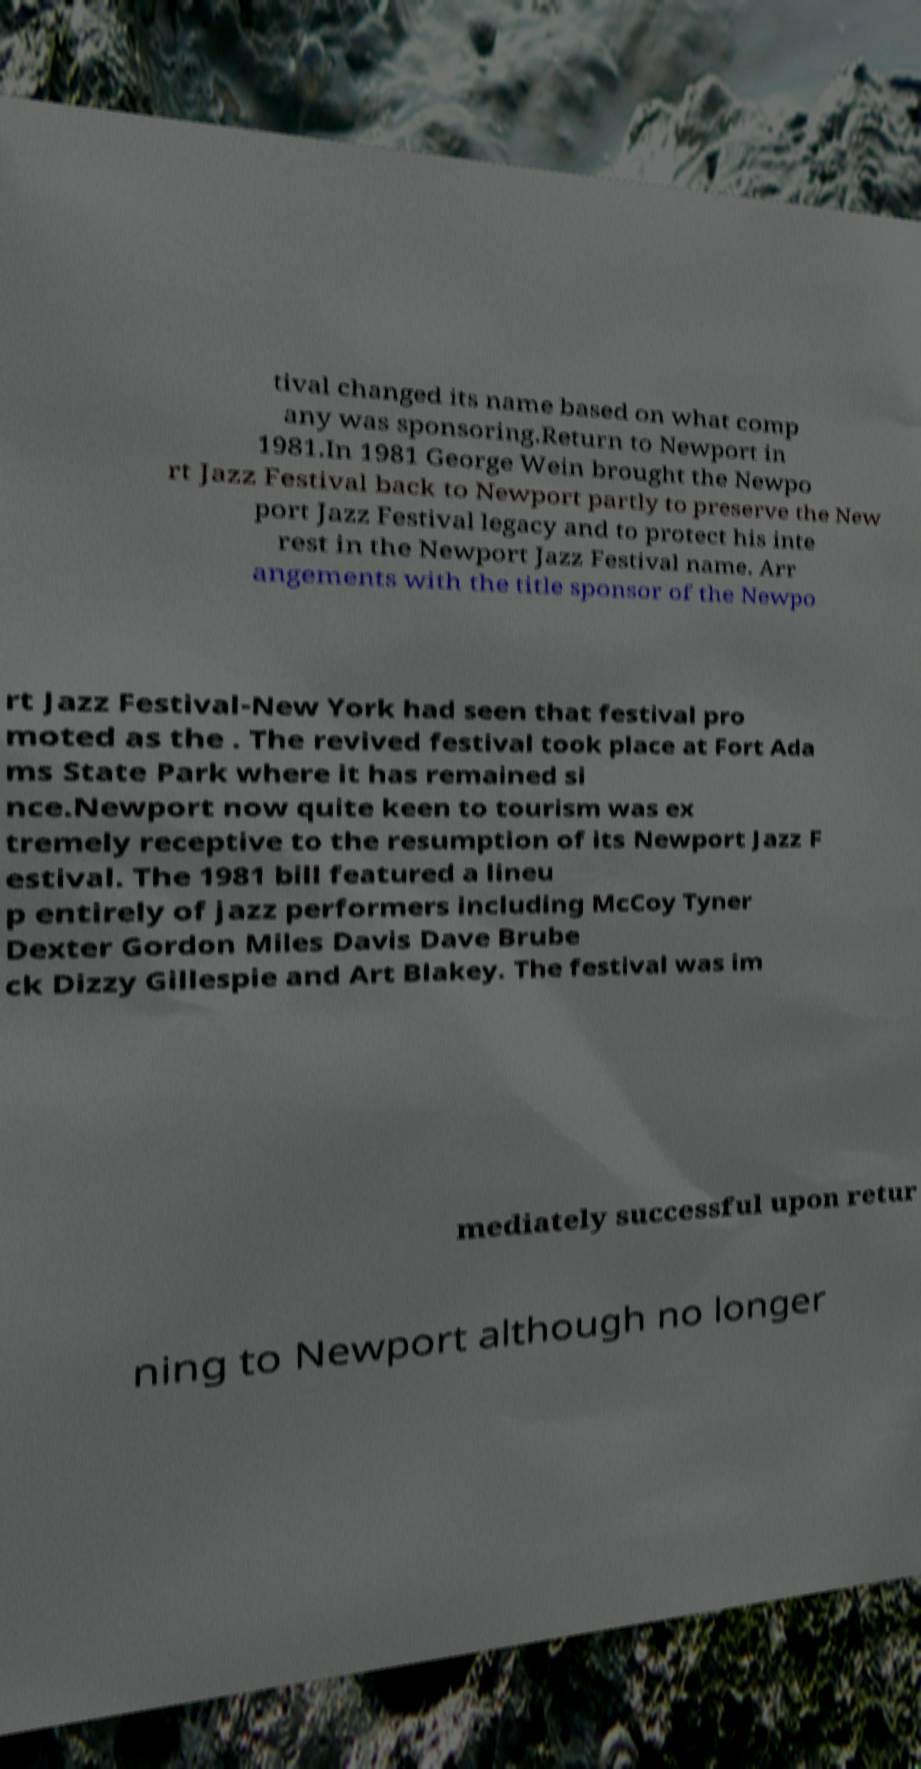For documentation purposes, I need the text within this image transcribed. Could you provide that? tival changed its name based on what comp any was sponsoring.Return to Newport in 1981.In 1981 George Wein brought the Newpo rt Jazz Festival back to Newport partly to preserve the New port Jazz Festival legacy and to protect his inte rest in the Newport Jazz Festival name. Arr angements with the title sponsor of the Newpo rt Jazz Festival-New York had seen that festival pro moted as the . The revived festival took place at Fort Ada ms State Park where it has remained si nce.Newport now quite keen to tourism was ex tremely receptive to the resumption of its Newport Jazz F estival. The 1981 bill featured a lineu p entirely of jazz performers including McCoy Tyner Dexter Gordon Miles Davis Dave Brube ck Dizzy Gillespie and Art Blakey. The festival was im mediately successful upon retur ning to Newport although no longer 